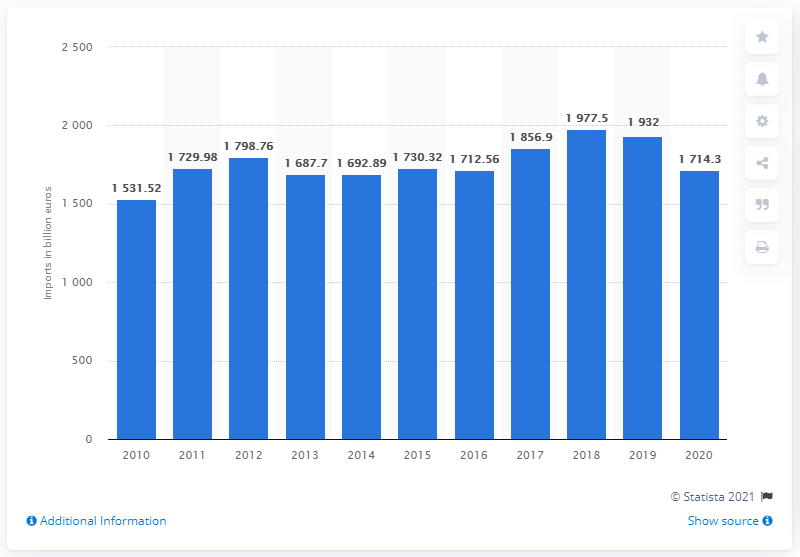List a handful of essential elements in this visual. In 2020, the value of goods imported by the EU was 17,143.3 million euros. 